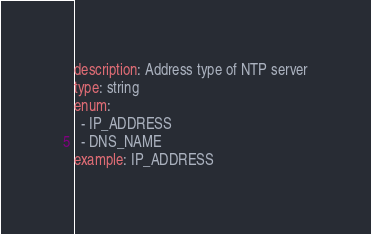Convert code to text. <code><loc_0><loc_0><loc_500><loc_500><_YAML_>description: Address type of NTP server
type: string
enum:
  - IP_ADDRESS
  - DNS_NAME
example: IP_ADDRESS</code> 